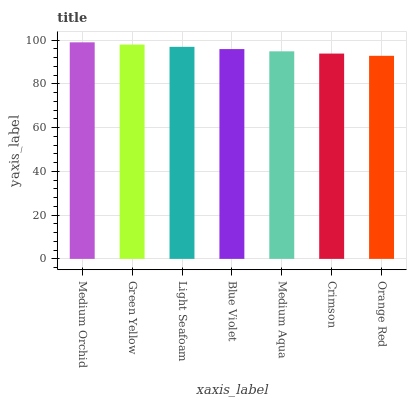Is Orange Red the minimum?
Answer yes or no. Yes. Is Medium Orchid the maximum?
Answer yes or no. Yes. Is Green Yellow the minimum?
Answer yes or no. No. Is Green Yellow the maximum?
Answer yes or no. No. Is Medium Orchid greater than Green Yellow?
Answer yes or no. Yes. Is Green Yellow less than Medium Orchid?
Answer yes or no. Yes. Is Green Yellow greater than Medium Orchid?
Answer yes or no. No. Is Medium Orchid less than Green Yellow?
Answer yes or no. No. Is Blue Violet the high median?
Answer yes or no. Yes. Is Blue Violet the low median?
Answer yes or no. Yes. Is Medium Aqua the high median?
Answer yes or no. No. Is Orange Red the low median?
Answer yes or no. No. 